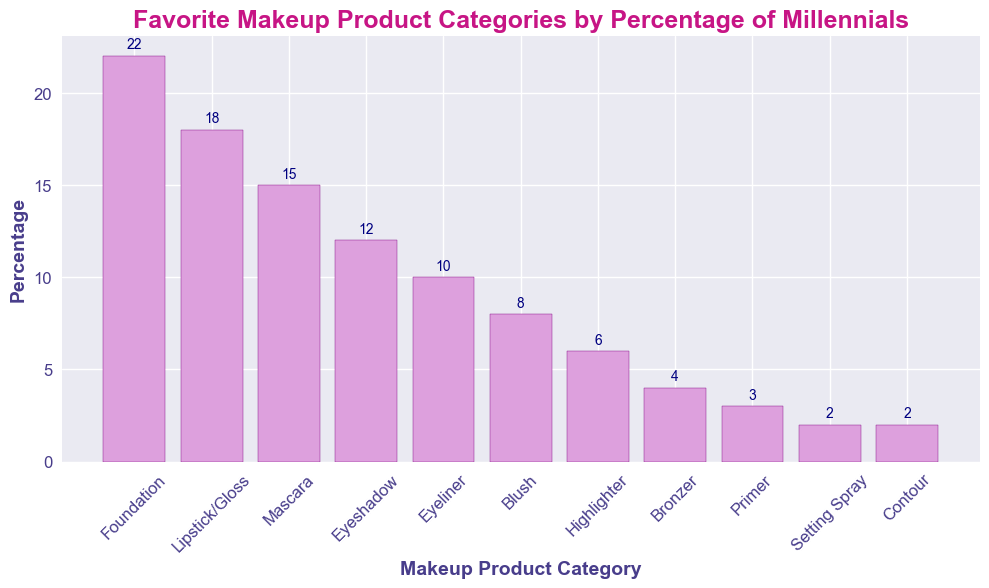Which makeup product category is the most popular? The bar chart shows the percentages of each makeup product category liked by millennials. The tallest bar represents the most popular category.
Answer: Foundation What's the total percentage of millennials who prefer Highlighter, Bronzer, and Contour combined? We need to sum the percentages for Highlighter (6%), Bronzer (4%), and Contour (2%). The sum is 6 + 4 + 2 = 12%.
Answer: 12% Which category has a higher percentage of preference: Eyeliner or Blush? We compare the heights of the bars for Eyeliner and Blush. The Eyeliner bar represents 10%, and the Blush bar represents 8%.
Answer: Eyeliner What's the difference in preference percentage between the most and least popular categories? The most popular category is Foundation at 22%, and the least popular categories are Setting Spray and Contour, each at 2%. The difference is 22 - 2 = 20%.
Answer: 20% What percentage of millennials prefer Lipstick/Gloss? The height of the Lipstick/Gloss bar shows the percentage preference for this category.
Answer: 18% How many categories have a preference percentage of less than 10%? The bars representing less than 10% are Blush (8%), Highlighter (6%), Bronzer (4%), Primer (3%), Setting Spray (2%), and Contour (2%). There are 6 such categories.
Answer: 6 Which is preferred more by millennials: Mascara or Eyeshadow? By comparing the heights of the bars, Mascara (15%) is preferred more than Eyeshadow (12%).
Answer: Mascara What's the average preference percentage for the top three product categories? The top three categories and their percentages are Foundation (22%), Lipstick/Gloss (18%), and Mascara (15%). The sum of these percentages is 22 + 18 + 15 = 55. The average is 55 / 3 = 18.33%.
Answer: 18.33% Is there any category where exactly 5% of millennials prefer it? We look at all the bars to see if any category has a percentage of exactly 5%. There's no bar representing 5%.
Answer: No What's the combined percentage for categories preferred by less than 5% of millennials? The categories preferred by less than 5% are Bronzer (4%), Primer (3%), Setting Spray (2%), and Contour (2%). The combined percentage is 4 + 3 + 2 + 2 = 11%.
Answer: 11% 